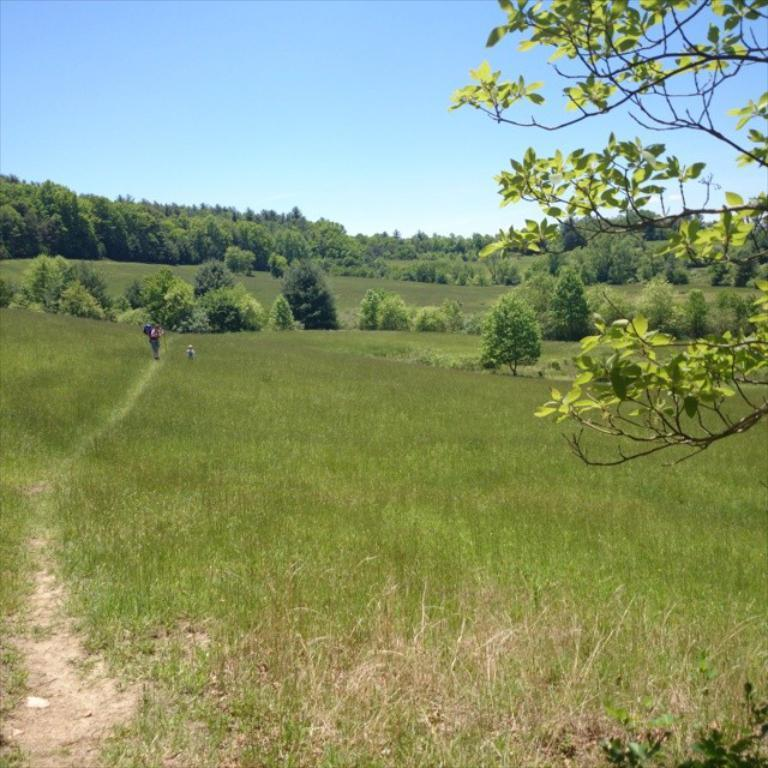What is the main subject of the image? There is a person standing in the image. What is the person standing on? The person is standing on grass. What can be seen in the background of the image? There are trees around the person. What type of alarm is the person holding in the image? There is no alarm present in the image; the person is not holding anything. 